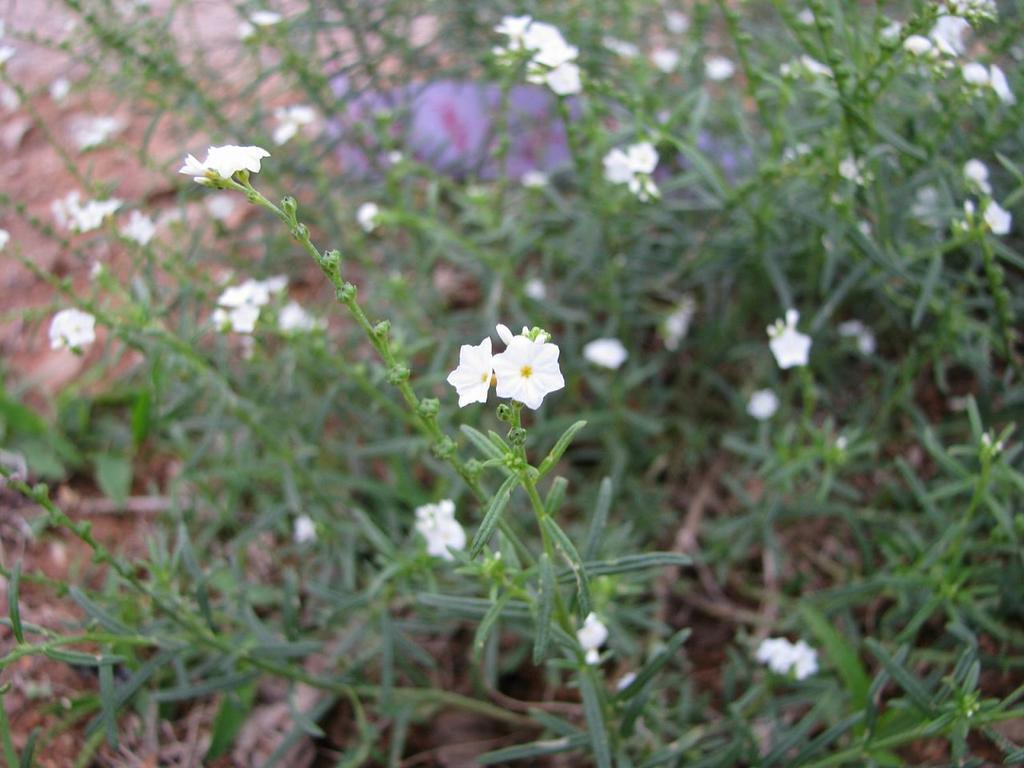What is the main subject in the middle of the image? There are small white flowers in the middle of the image. What can be seen in the background of the image? There are green plants on the ground in the background of the image. How many kittens are playing in the quicksand in the image? There are no kittens or quicksand present in the image. 